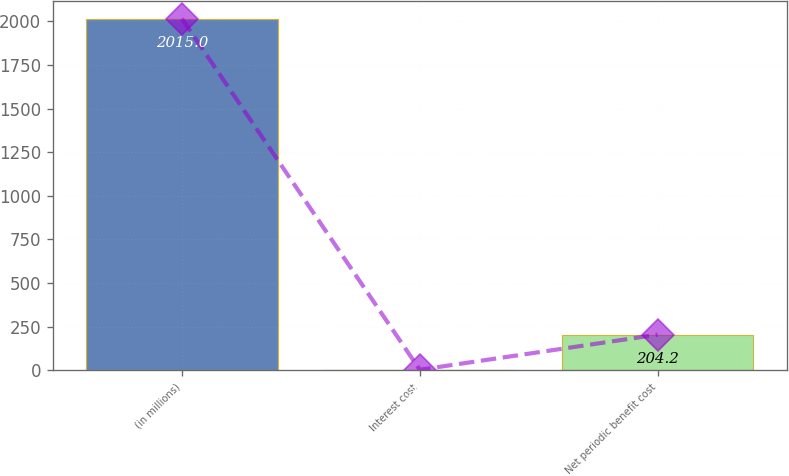Convert chart. <chart><loc_0><loc_0><loc_500><loc_500><bar_chart><fcel>(in millions)<fcel>Interest cost<fcel>Net periodic benefit cost<nl><fcel>2015<fcel>3<fcel>204.2<nl></chart> 